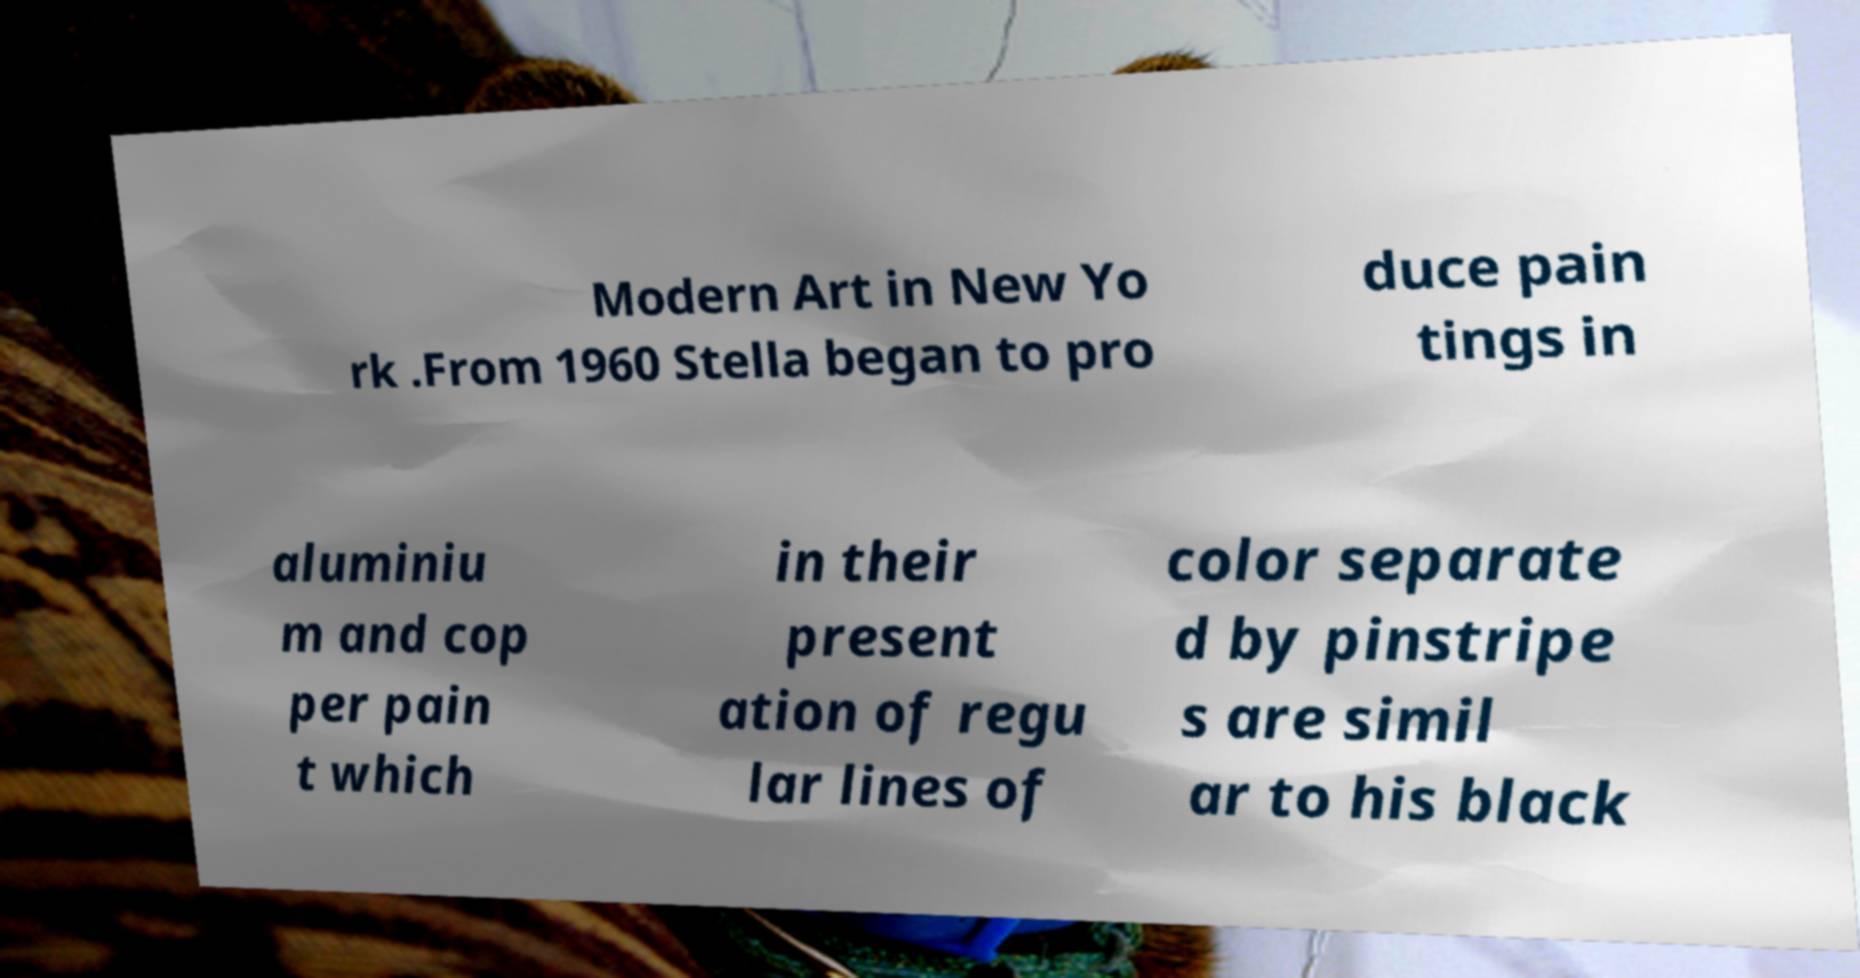Can you read and provide the text displayed in the image?This photo seems to have some interesting text. Can you extract and type it out for me? Modern Art in New Yo rk .From 1960 Stella began to pro duce pain tings in aluminiu m and cop per pain t which in their present ation of regu lar lines of color separate d by pinstripe s are simil ar to his black 